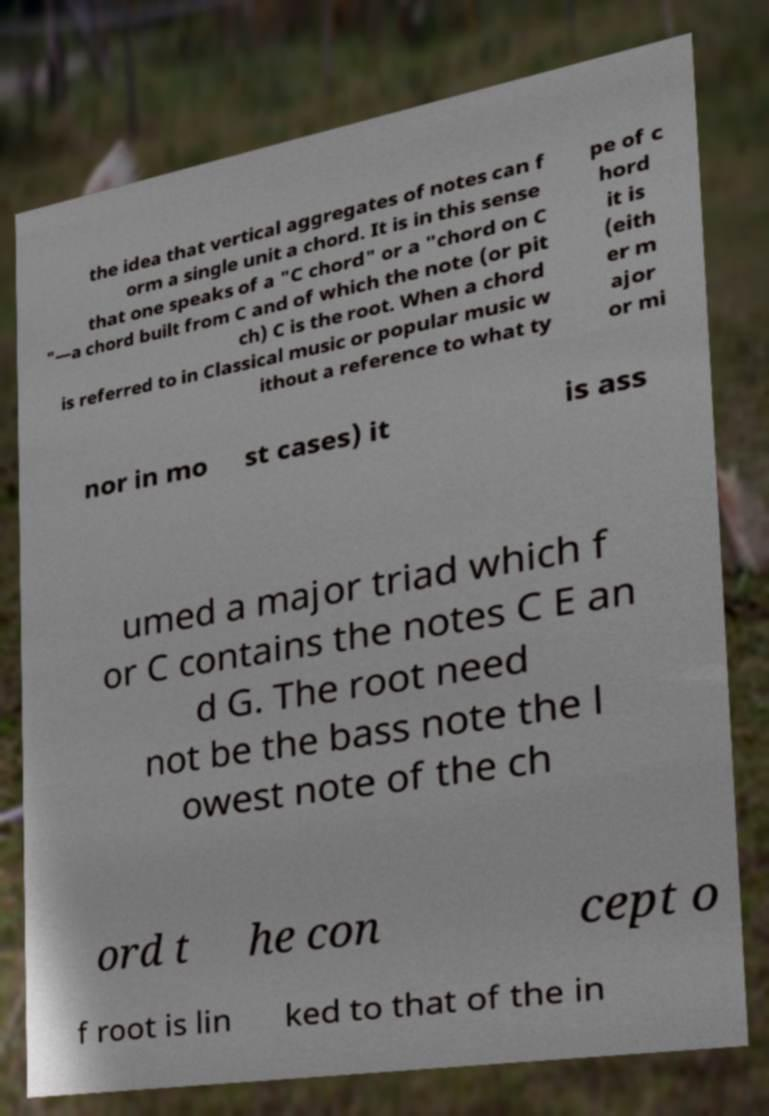Please read and relay the text visible in this image. What does it say? the idea that vertical aggregates of notes can f orm a single unit a chord. It is in this sense that one speaks of a "C chord" or a "chord on C "—a chord built from C and of which the note (or pit ch) C is the root. When a chord is referred to in Classical music or popular music w ithout a reference to what ty pe of c hord it is (eith er m ajor or mi nor in mo st cases) it is ass umed a major triad which f or C contains the notes C E an d G. The root need not be the bass note the l owest note of the ch ord t he con cept o f root is lin ked to that of the in 